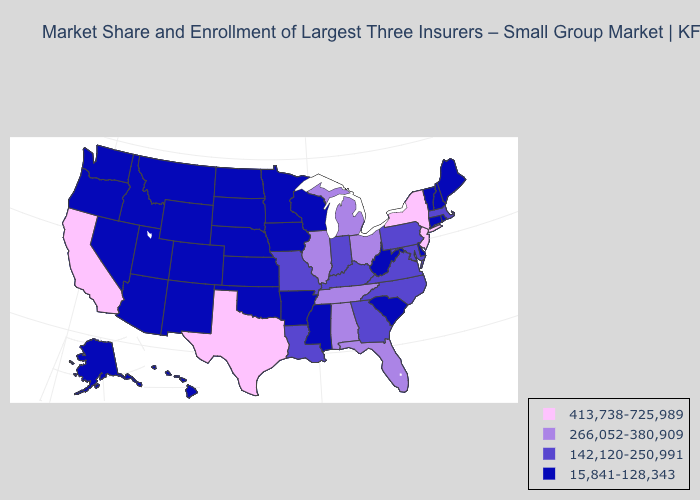Name the states that have a value in the range 15,841-128,343?
Keep it brief. Alaska, Arizona, Arkansas, Colorado, Connecticut, Delaware, Hawaii, Idaho, Iowa, Kansas, Maine, Minnesota, Mississippi, Montana, Nebraska, Nevada, New Hampshire, New Mexico, North Dakota, Oklahoma, Oregon, Rhode Island, South Carolina, South Dakota, Utah, Vermont, Washington, West Virginia, Wisconsin, Wyoming. Which states have the highest value in the USA?
Be succinct. California, New Jersey, New York, Texas. Does the first symbol in the legend represent the smallest category?
Give a very brief answer. No. Name the states that have a value in the range 266,052-380,909?
Short answer required. Alabama, Florida, Illinois, Michigan, Ohio, Tennessee. What is the lowest value in states that border Georgia?
Short answer required. 15,841-128,343. Among the states that border North Carolina , does Georgia have the lowest value?
Short answer required. No. What is the lowest value in the MidWest?
Quick response, please. 15,841-128,343. What is the lowest value in states that border California?
Answer briefly. 15,841-128,343. Among the states that border South Dakota , which have the lowest value?
Quick response, please. Iowa, Minnesota, Montana, Nebraska, North Dakota, Wyoming. Name the states that have a value in the range 413,738-725,989?
Answer briefly. California, New Jersey, New York, Texas. Name the states that have a value in the range 142,120-250,991?
Write a very short answer. Georgia, Indiana, Kentucky, Louisiana, Maryland, Massachusetts, Missouri, North Carolina, Pennsylvania, Virginia. What is the highest value in the South ?
Answer briefly. 413,738-725,989. Does Missouri have the lowest value in the MidWest?
Short answer required. No. Does New York have a higher value than California?
Answer briefly. No. What is the value of New Hampshire?
Give a very brief answer. 15,841-128,343. 